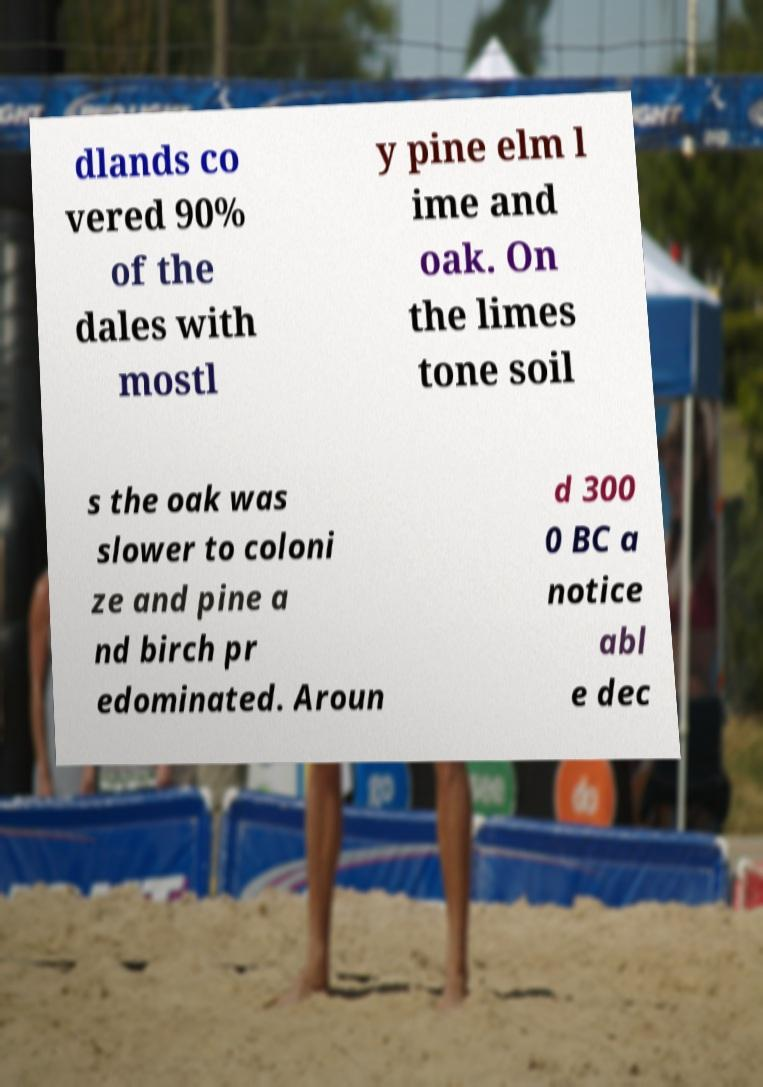For documentation purposes, I need the text within this image transcribed. Could you provide that? dlands co vered 90% of the dales with mostl y pine elm l ime and oak. On the limes tone soil s the oak was slower to coloni ze and pine a nd birch pr edominated. Aroun d 300 0 BC a notice abl e dec 